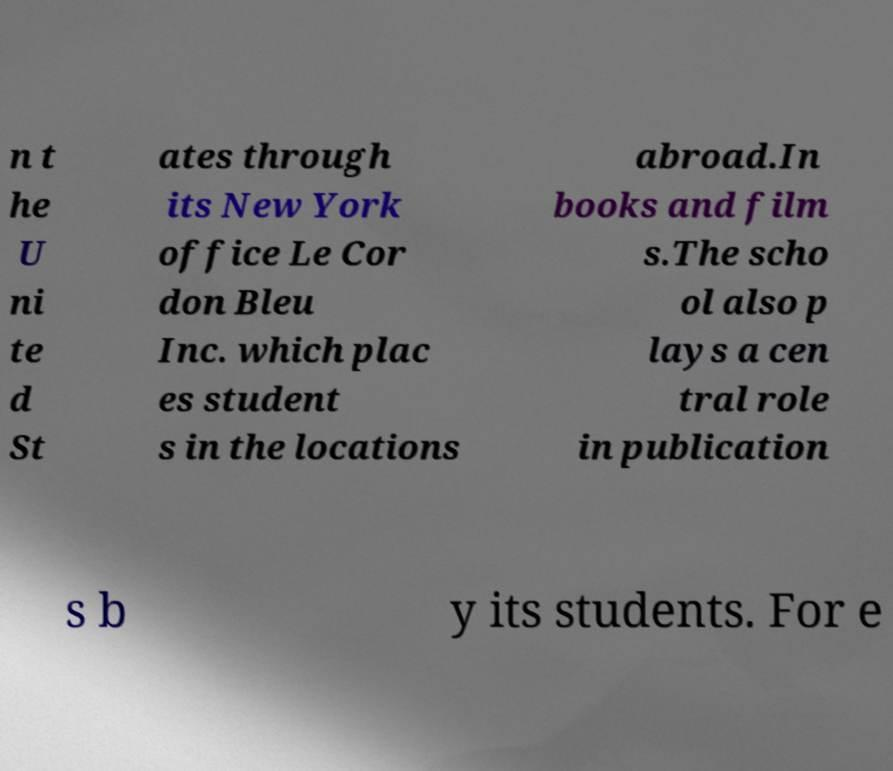Please read and relay the text visible in this image. What does it say? n t he U ni te d St ates through its New York office Le Cor don Bleu Inc. which plac es student s in the locations abroad.In books and film s.The scho ol also p lays a cen tral role in publication s b y its students. For e 